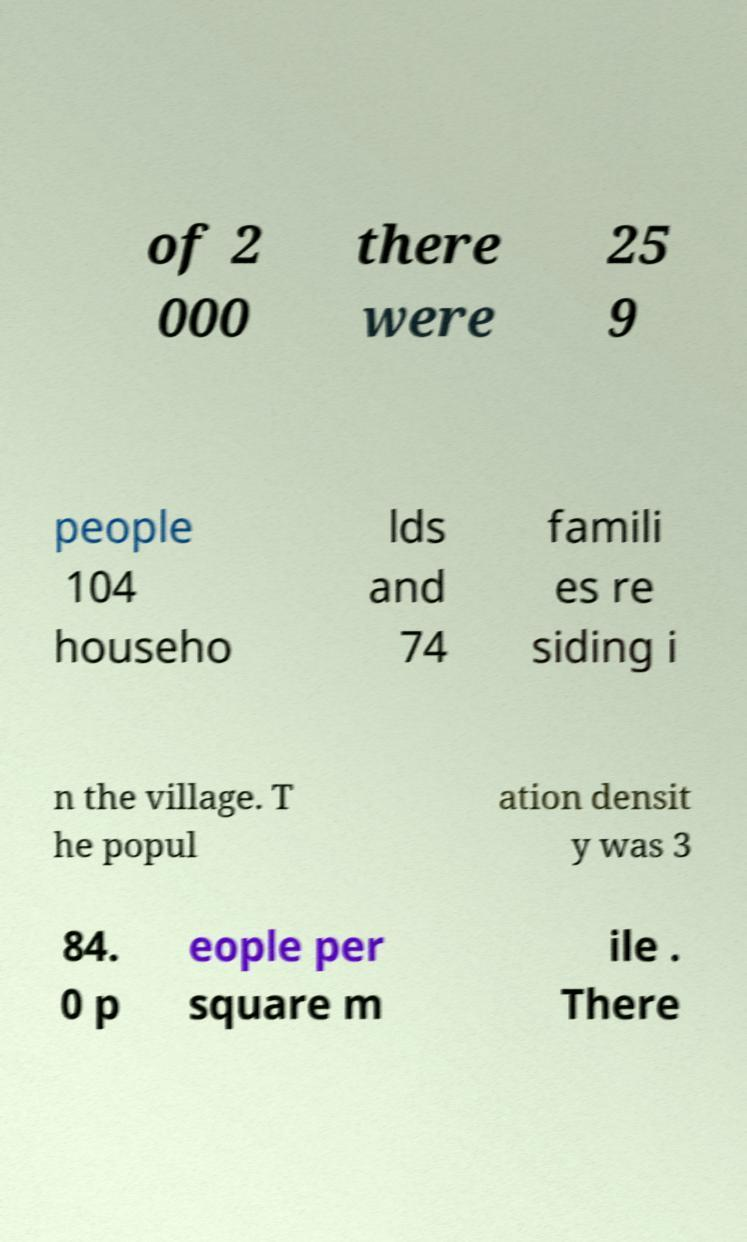For documentation purposes, I need the text within this image transcribed. Could you provide that? of 2 000 there were 25 9 people 104 househo lds and 74 famili es re siding i n the village. T he popul ation densit y was 3 84. 0 p eople per square m ile . There 